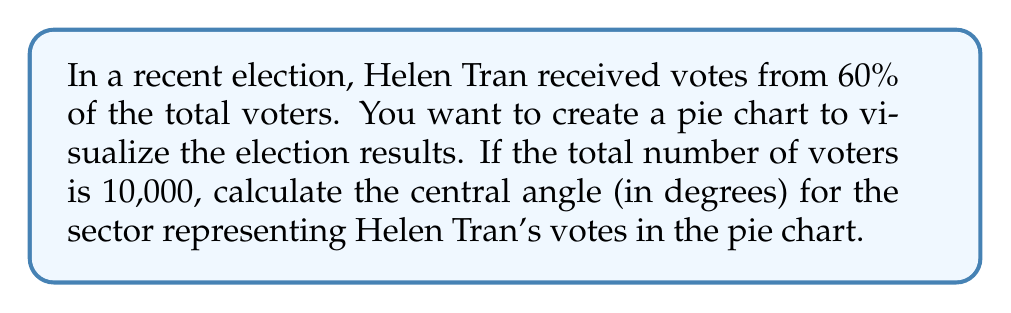Help me with this question. To solve this problem, we need to follow these steps:

1. Calculate the number of votes Helen Tran received:
   Helen Tran's votes = 60% of total voters
   $$ \text{Helen Tran's votes} = 0.60 \times 10,000 = 6,000 \text{ votes} $$

2. Determine the proportion of Helen Tran's votes to the total votes:
   $$ \text{Proportion} = \frac{\text{Helen Tran's votes}}{\text{Total votes}} = \frac{6,000}{10,000} = 0.60 $$

3. Calculate the central angle for Helen Tran's sector:
   In a pie chart, the full circle represents 360°. The central angle for Helen Tran's sector will be proportional to her share of the votes.

   $$ \text{Central angle} = \text{Proportion} \times 360° $$
   $$ \text{Central angle} = 0.60 \times 360° = 216° $$

Therefore, the central angle for the sector representing Helen Tran's votes in the pie chart is 216°.
Answer: 216° 